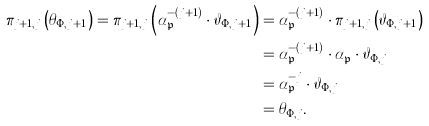<formula> <loc_0><loc_0><loc_500><loc_500>\pi _ { j + 1 , j } \left ( \theta _ { \Phi , j + 1 } \right ) = \pi _ { j + 1 , j } \left ( \alpha _ { \mathfrak { p } } ^ { - ( j + 1 ) } \cdot \vartheta _ { \Phi , j + 1 } \right ) & = \alpha _ { \mathfrak { p } } ^ { - ( j + 1 ) } \cdot \pi _ { j + 1 , j } \left ( \vartheta _ { \Phi , j + 1 } \right ) \\ & = \alpha _ { \mathfrak { p } } ^ { - ( j + 1 ) } \cdot \alpha _ { \mathfrak { p } } \cdot \vartheta _ { \Phi , j } \\ & = \alpha _ { \mathfrak { p } } ^ { - j } \cdot \vartheta _ { \Phi , j } \\ & = \theta _ { \Phi , j } .</formula> 